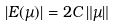<formula> <loc_0><loc_0><loc_500><loc_500>\left | E ( \mu ) \right | = 2 C \left \| \mu \right \|</formula> 